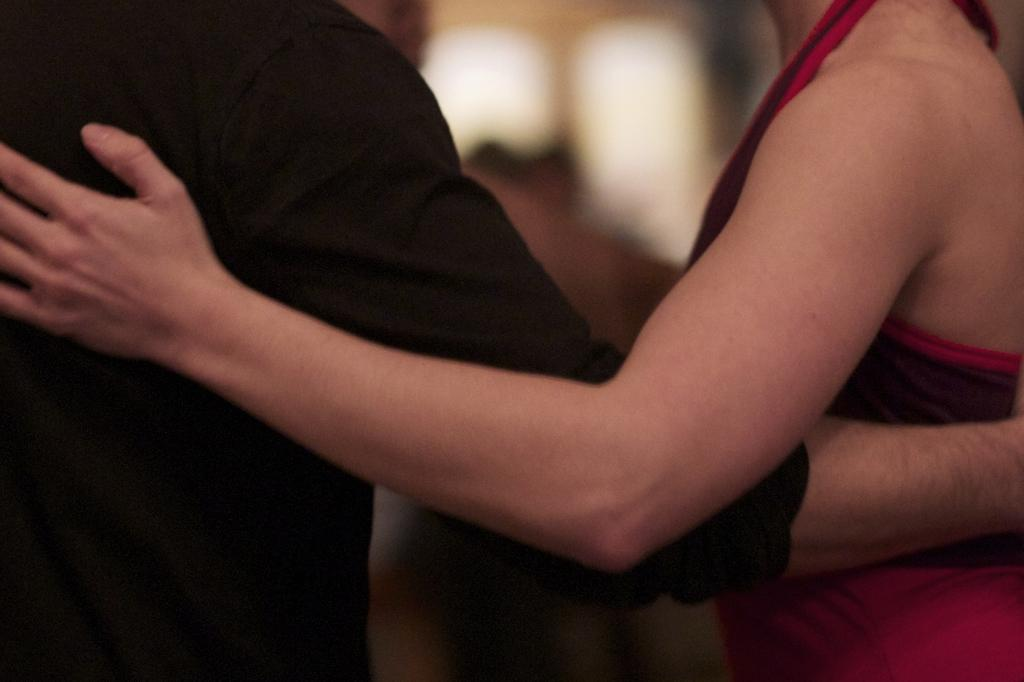How many people are in the image? There are persons in the image. What are the persons wearing? The persons are wearing clothes. Are the persons in the image sisters? There is no information in the image to determine if the persons are sisters or not. Is there a veil visible on any of the persons in the image? There is no mention of a veil in the provided facts, so it cannot be determined if one is present in the image. 